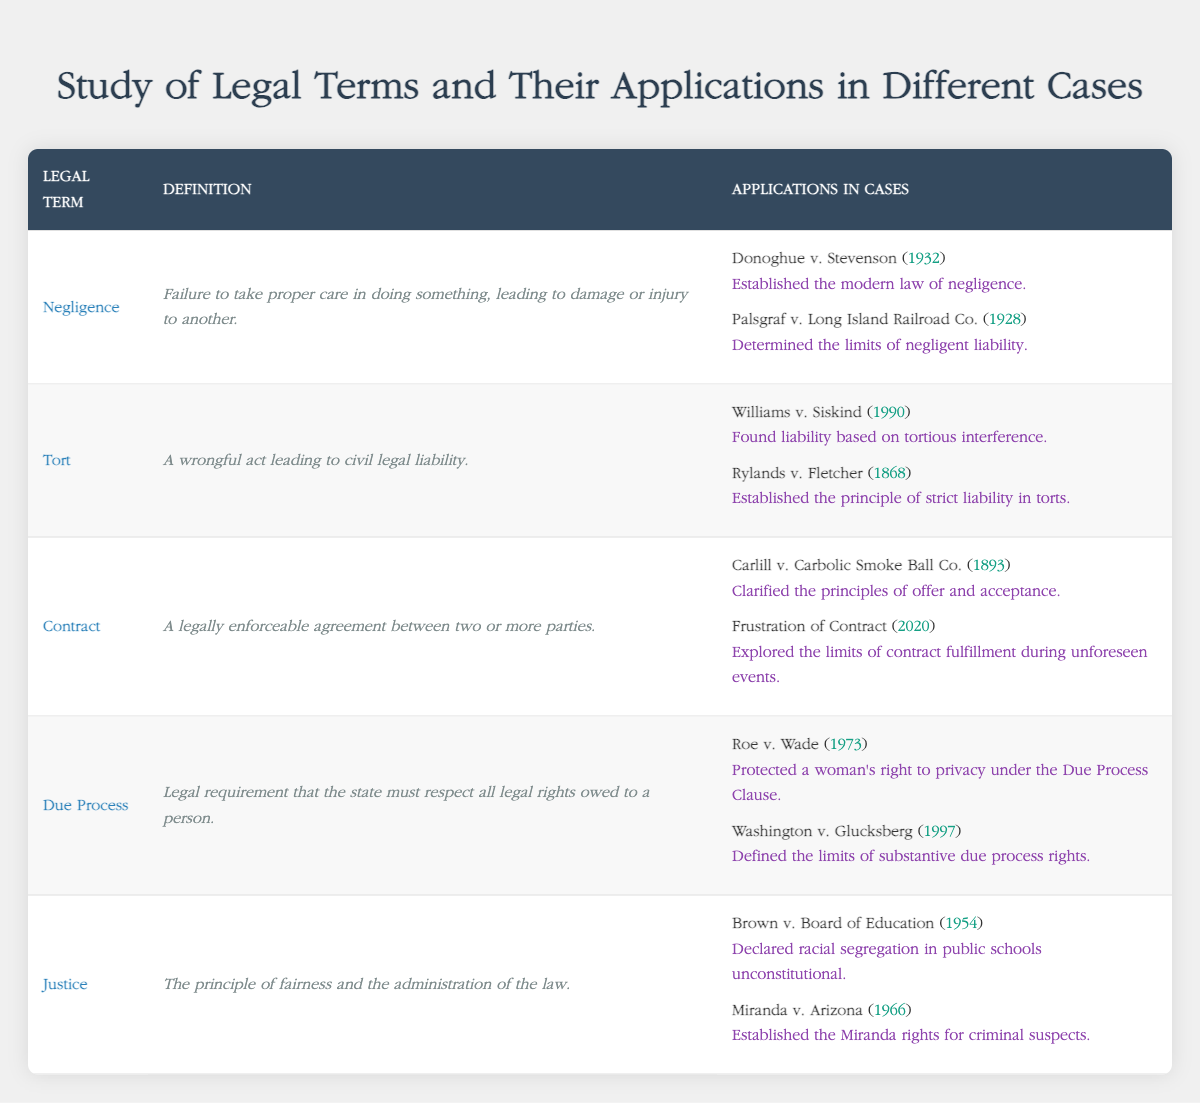What legal term is defined as "Failure to take proper care in doing something, leading to damage or injury to another."? The description in the table specifically states that this definition corresponds to the legal term "Negligence".
Answer: Negligence In which case did the principle of "strict liability in torts" get established? By referring to the applications in the table, "Rylands v. Fletcher" from the year 1868 is noted as establishing the principle of strict liability in torts.
Answer: Rylands v. Fletcher How many applications are listed for the legal term "Due Process"? The table shows two cases that apply to the term "Due Process": "Roe v. Wade" and "Washington v. Glucksberg", which results in a total of two applications.
Answer: 2 Is "Miranda v. Arizona" related to the legal term "Justice"? The case "Miranda v. Arizona" is listed under the legal term "Justice" in the applications section of the table, confirming that it is related to this term.
Answer: Yes What year was the case "Carlill v. Carbolic Smoke Ball Co." decided? Looking at the table, the case "Carlill v. Carbolic Smoke Ball Co." is associated with the year 1893, as noted directly in the table.
Answer: 1893 Which legal term has the most recent case listed? The most recent case in the table is "Frustration of Contract" from 2020, which falls under the legal term "Contract". Comparing the years of the last listed cases for all legal terms, "Contract" has the most recent outcome.
Answer: Contract What are the years of the cases that involved "Negligence"? The table presents two cases under "Negligence": "Donoghue v. Stevenson" (1932) and "Palsgraf v. Long Island Railroad Co." (1928). The corresponding years are therefore 1932 and 1928.
Answer: 1932, 1928 Which legal term is associated with the case "Brown v. Board of Education"? According to the table, "Brown v. Board of Education" is linked to the legal term "Justice," as it is listed under that category within the application section.
Answer: Justice List the outcomes related to "Tort" as described in the table. From the table, the outcomes associated with "Tort" are "Found liability based on tortious interference" for "Williams v. Siskind" and "Established the principle of strict liability in torts" for "Rylands v. Fletcher".
Answer: Found liability based on tortious interference; Established the principle of strict liability in torts 